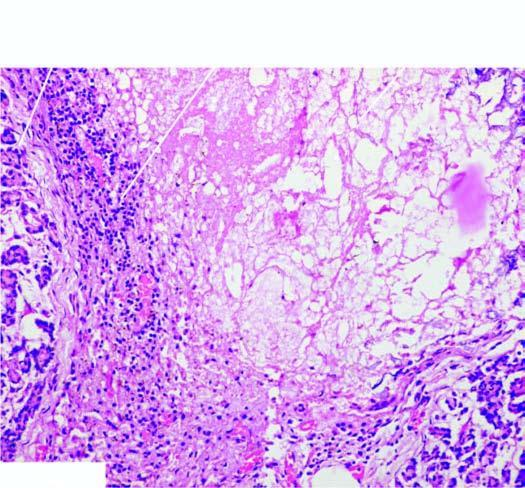what is there of dystrophic calcification?
Answer the question using a single word or phrase. Presence 